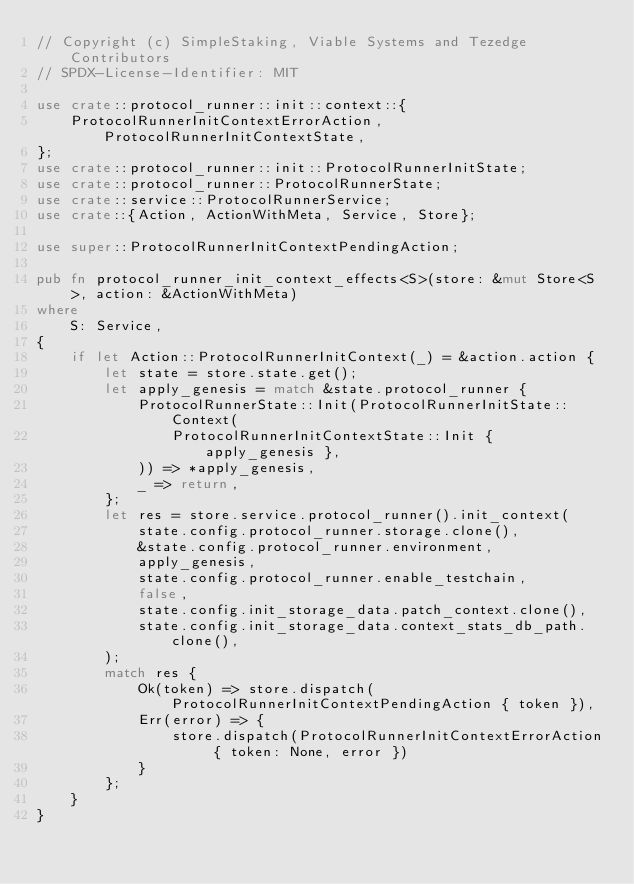Convert code to text. <code><loc_0><loc_0><loc_500><loc_500><_Rust_>// Copyright (c) SimpleStaking, Viable Systems and Tezedge Contributors
// SPDX-License-Identifier: MIT

use crate::protocol_runner::init::context::{
    ProtocolRunnerInitContextErrorAction, ProtocolRunnerInitContextState,
};
use crate::protocol_runner::init::ProtocolRunnerInitState;
use crate::protocol_runner::ProtocolRunnerState;
use crate::service::ProtocolRunnerService;
use crate::{Action, ActionWithMeta, Service, Store};

use super::ProtocolRunnerInitContextPendingAction;

pub fn protocol_runner_init_context_effects<S>(store: &mut Store<S>, action: &ActionWithMeta)
where
    S: Service,
{
    if let Action::ProtocolRunnerInitContext(_) = &action.action {
        let state = store.state.get();
        let apply_genesis = match &state.protocol_runner {
            ProtocolRunnerState::Init(ProtocolRunnerInitState::Context(
                ProtocolRunnerInitContextState::Init { apply_genesis },
            )) => *apply_genesis,
            _ => return,
        };
        let res = store.service.protocol_runner().init_context(
            state.config.protocol_runner.storage.clone(),
            &state.config.protocol_runner.environment,
            apply_genesis,
            state.config.protocol_runner.enable_testchain,
            false,
            state.config.init_storage_data.patch_context.clone(),
            state.config.init_storage_data.context_stats_db_path.clone(),
        );
        match res {
            Ok(token) => store.dispatch(ProtocolRunnerInitContextPendingAction { token }),
            Err(error) => {
                store.dispatch(ProtocolRunnerInitContextErrorAction { token: None, error })
            }
        };
    }
}
</code> 